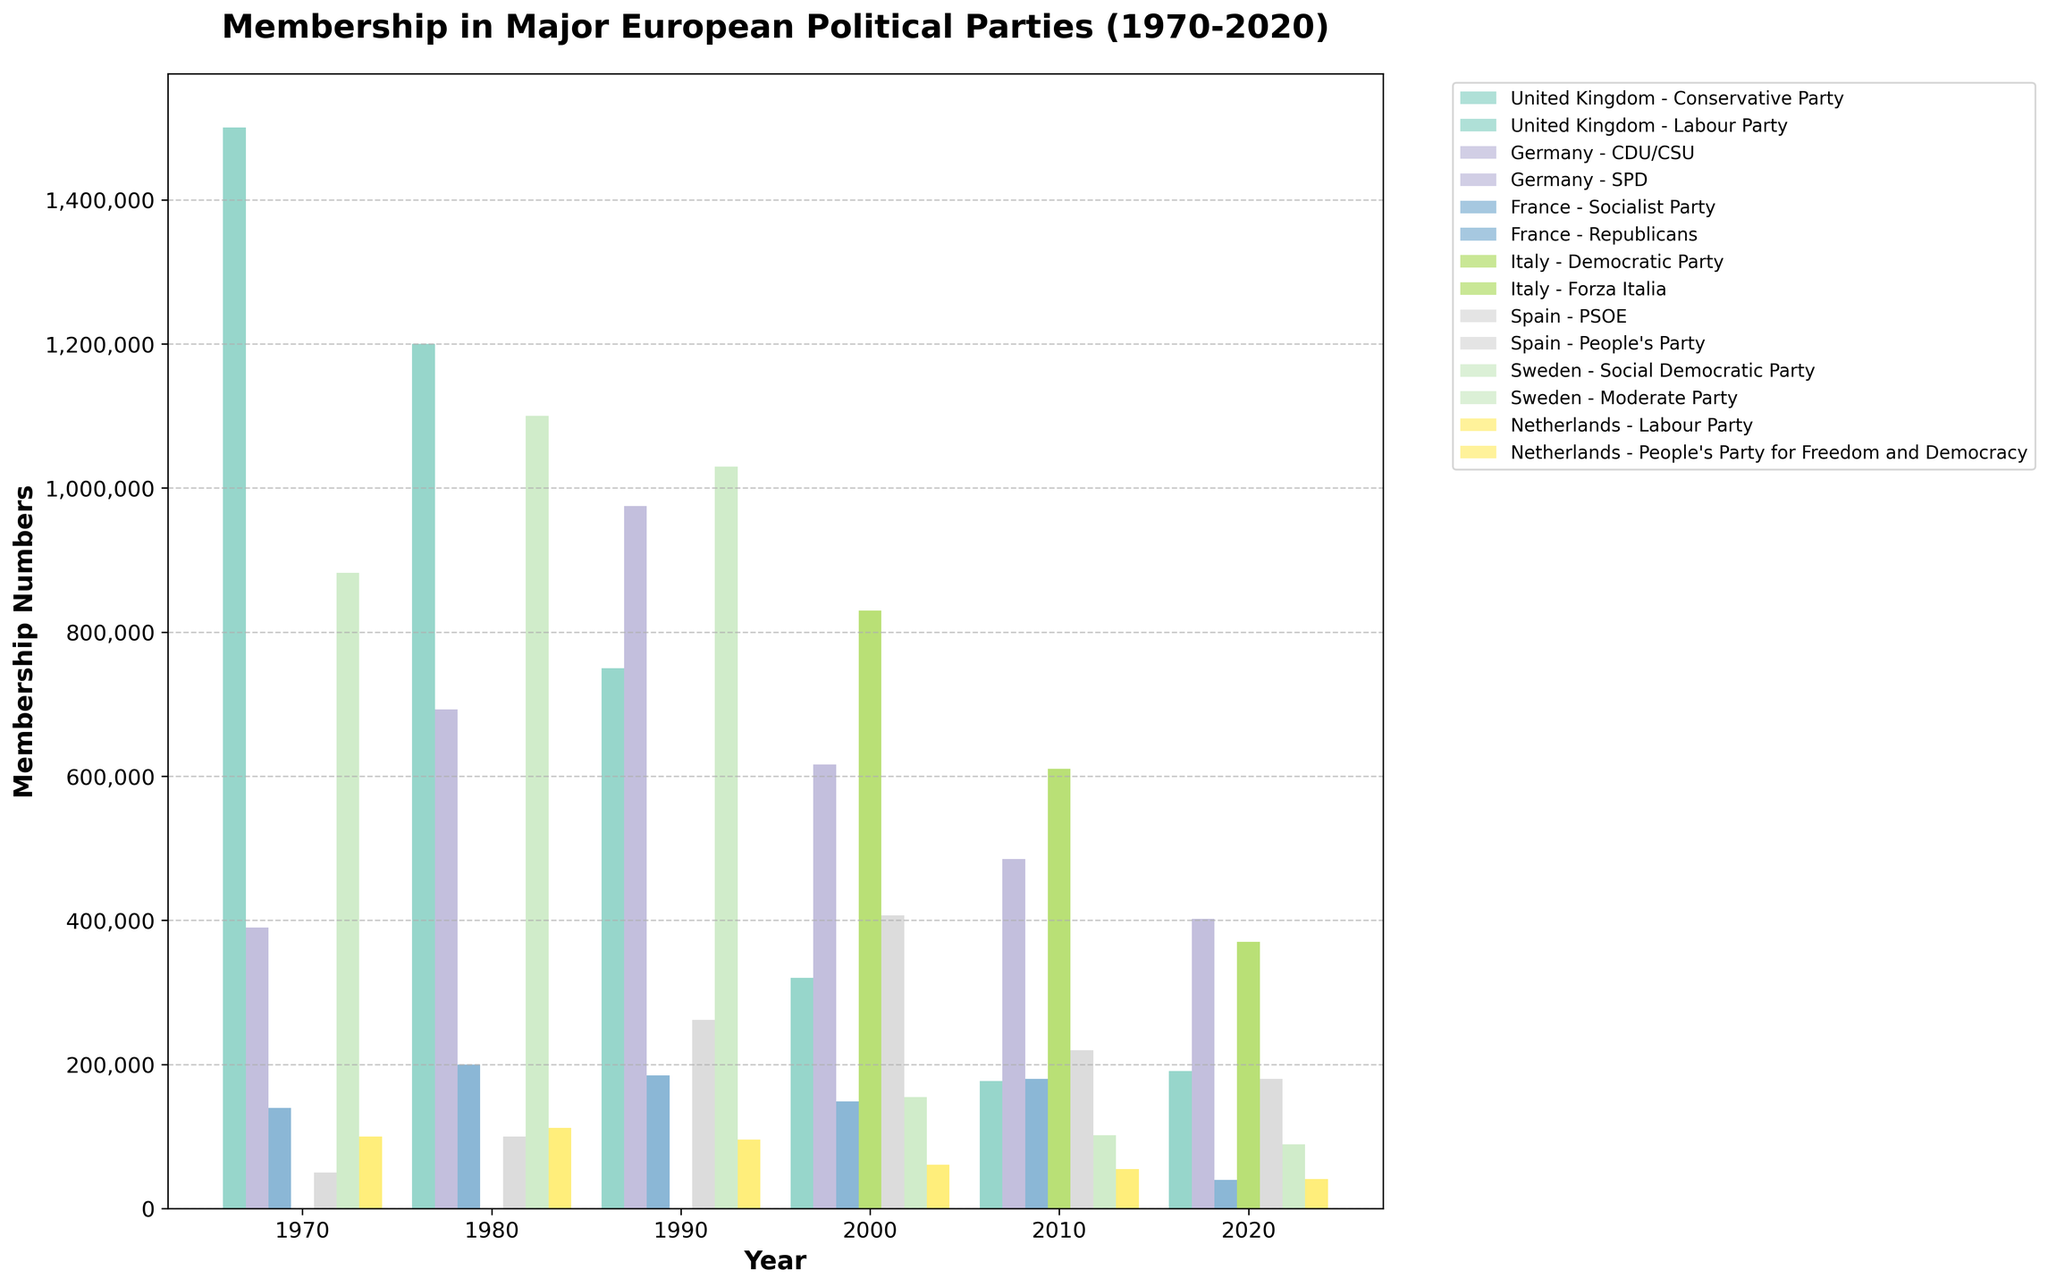Which political party in the United Kingdom showed a significant increase in membership from 2010 to 2020? To answer this, look at the UK parties' membership data for 2010 and 2020. The Labour Party increased from 193,000 in 2010 to 495,000 in 2020, while the Conservative Party saw a minor increase from 177,000 to 191,000. Thus, the Labour Party had the significant increase.
Answer: Labour Party Which country had the highest total party membership in 1980? Review the membership numbers for all parties across countries in 1980. For the UK, sum Labour (348,000) and Conservative (1,200,000); for Germany, sum CDU/CSU (693,000) and SPD (986,000); for France, sum Socialist (200,000) and Republicans (145,000); etc. Germany has the highest sum (693,000 + 986,000 = 1,679,000).
Answer: Germany Which Swedish political party saw a greater decrease in membership from 1980 to 2020, the Social Democratic Party or the Moderate Party? Compare the membership numbers of both parties in 1980 and 2020. Social Democratic Party dropped from 1,100,000 to 89,000 (a decrease of 1,011,000), while Moderate Party dropped from 145,000 to 62,000 (a decrease of 83,000). Thus, the Social Democratic Party had a greater decrease.
Answer: Social Democratic Party Between the French Socialist Party and the German SPD, which had a larger membership in 2000? Compare the membership numbers of these two parties in the year 2000. The French Socialist Party had 149,000 members, while the German SPD had 735,000 members, thus the German SPD had a larger membership.
Answer: German SPD How did the membership numbers for Italy's Democratic Party change from 2000 to 2020? Calculate the difference in membership numbers from 2000 (830,000) to 2020 (370,000). The decrease is 830,000 - 370,000 = 460,000.
Answer: Decreased by 460,000 What is the combined membership of the People’s Party in Spain and the People’s Party for Freedom and Democracy in the Netherlands in the year 2020? Add the membership of the People’s Party in Spain (520,000) and the People’s Party for Freedom and Democracy in the Netherlands (25,000) for the year 2020. 520,000 + 25,000 = 545,000.
Answer: 545,000 Which country had the most balanced membership numbers between its two biggest parties in 2020? Compare the difference in membership numbers between the two biggest parties in each country in 2020. For the UK, it's 304,000; Germany, 2,000; France, 0; Italy, 270,000; Spain, 340,000; Sweden, 27,000; Netherlands, 16,000. The smallest difference (most balanced) is in France (80,000 vs. 80,000).
Answer: France Which political party in Germany had a higher membership number in 1990, CDU/CSU or SPD? Look at the membership numbers for CDU/CSU (975,000) and SPD (943,000) in 1990. CDU/CSU had higher membership than SPD (975,000 > 943,000).
Answer: CDU/CSU By how much did the membership of the UK's Conservative Party decrease from 1970 to 2000? Subtract the 2000 membership number (320,000) from the 1970 membership number (1,500,000): 1,500,000 - 320,000 = 1,180,000.
Answer: 1,180,000 Which of the countries listed had at least one party with membership consistently declining from 1970 to 2020? Check each party's trend line from 1970 to 2020. The UK's Labour Party shows a decline, and the Conservative Party also shows mostly declining numbers with minor fluctuations. Thus, the United Kingdom fits this description.
Answer: United Kingdom 